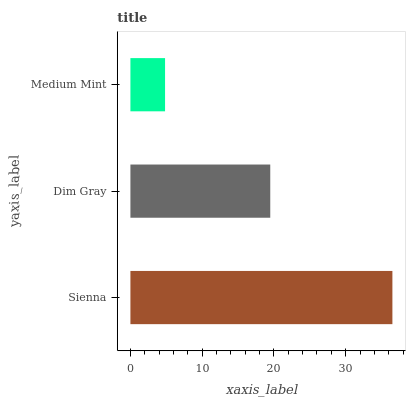Is Medium Mint the minimum?
Answer yes or no. Yes. Is Sienna the maximum?
Answer yes or no. Yes. Is Dim Gray the minimum?
Answer yes or no. No. Is Dim Gray the maximum?
Answer yes or no. No. Is Sienna greater than Dim Gray?
Answer yes or no. Yes. Is Dim Gray less than Sienna?
Answer yes or no. Yes. Is Dim Gray greater than Sienna?
Answer yes or no. No. Is Sienna less than Dim Gray?
Answer yes or no. No. Is Dim Gray the high median?
Answer yes or no. Yes. Is Dim Gray the low median?
Answer yes or no. Yes. Is Sienna the high median?
Answer yes or no. No. Is Sienna the low median?
Answer yes or no. No. 